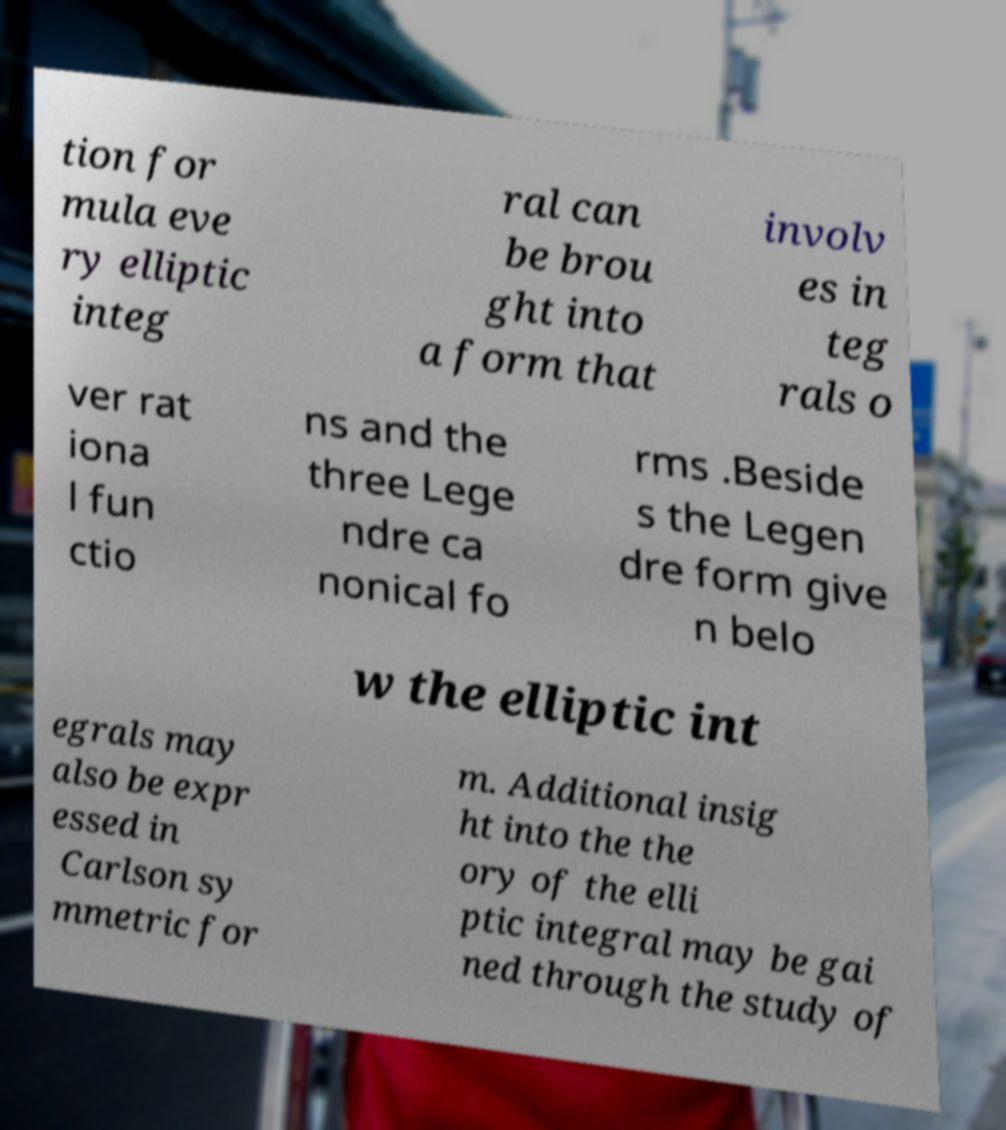For documentation purposes, I need the text within this image transcribed. Could you provide that? tion for mula eve ry elliptic integ ral can be brou ght into a form that involv es in teg rals o ver rat iona l fun ctio ns and the three Lege ndre ca nonical fo rms .Beside s the Legen dre form give n belo w the elliptic int egrals may also be expr essed in Carlson sy mmetric for m. Additional insig ht into the the ory of the elli ptic integral may be gai ned through the study of 